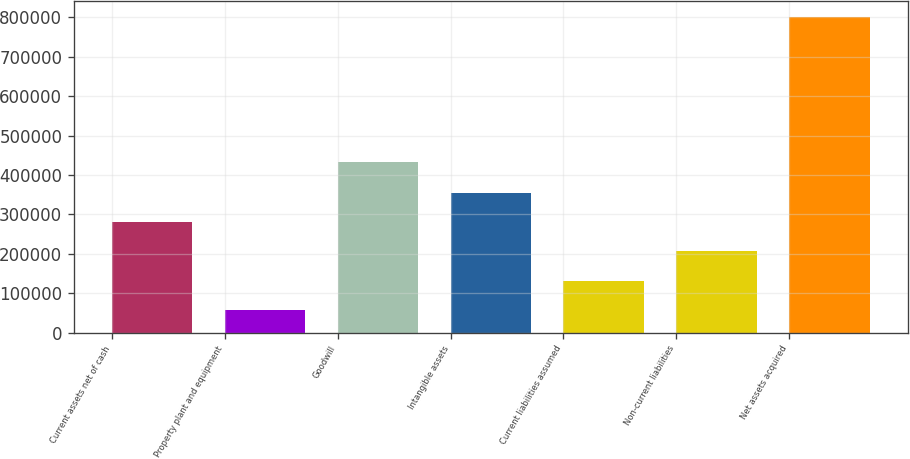Convert chart to OTSL. <chart><loc_0><loc_0><loc_500><loc_500><bar_chart><fcel>Current assets net of cash<fcel>Property plant and equipment<fcel>Goodwill<fcel>Intangible assets<fcel>Current liabilities assumed<fcel>Non-current liabilities<fcel>Net assets acquired<nl><fcel>280764<fcel>57269<fcel>432138<fcel>355263<fcel>131768<fcel>206266<fcel>802254<nl></chart> 